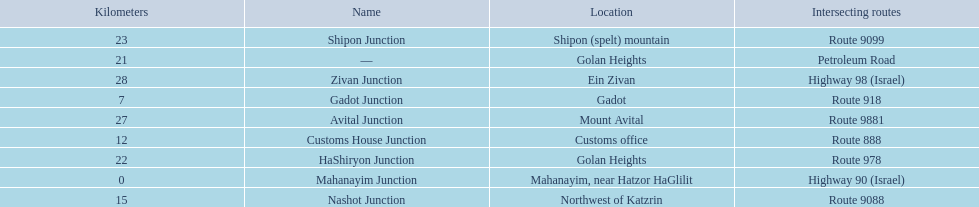What are all of the junction names? Mahanayim Junction, Gadot Junction, Customs House Junction, Nashot Junction, —, HaShiryon Junction, Shipon Junction, Avital Junction, Zivan Junction. What are their locations in kilometers? 0, 7, 12, 15, 21, 22, 23, 27, 28. Would you be able to parse every entry in this table? {'header': ['Kilometers', 'Name', 'Location', 'Intersecting routes'], 'rows': [['23', 'Shipon Junction', 'Shipon (spelt) mountain', 'Route 9099'], ['21', '—', 'Golan Heights', 'Petroleum Road'], ['28', 'Zivan Junction', 'Ein Zivan', 'Highway 98 (Israel)'], ['7', 'Gadot Junction', 'Gadot', 'Route 918'], ['27', 'Avital Junction', 'Mount Avital', 'Route 9881'], ['12', 'Customs House Junction', 'Customs office', 'Route 888'], ['22', 'HaShiryon Junction', 'Golan Heights', 'Route 978'], ['0', 'Mahanayim Junction', 'Mahanayim, near Hatzor HaGlilit', 'Highway 90 (Israel)'], ['15', 'Nashot Junction', 'Northwest of Katzrin', 'Route 9088']]} Between shipon and avital, whicih is nashot closer to? Shipon Junction. 